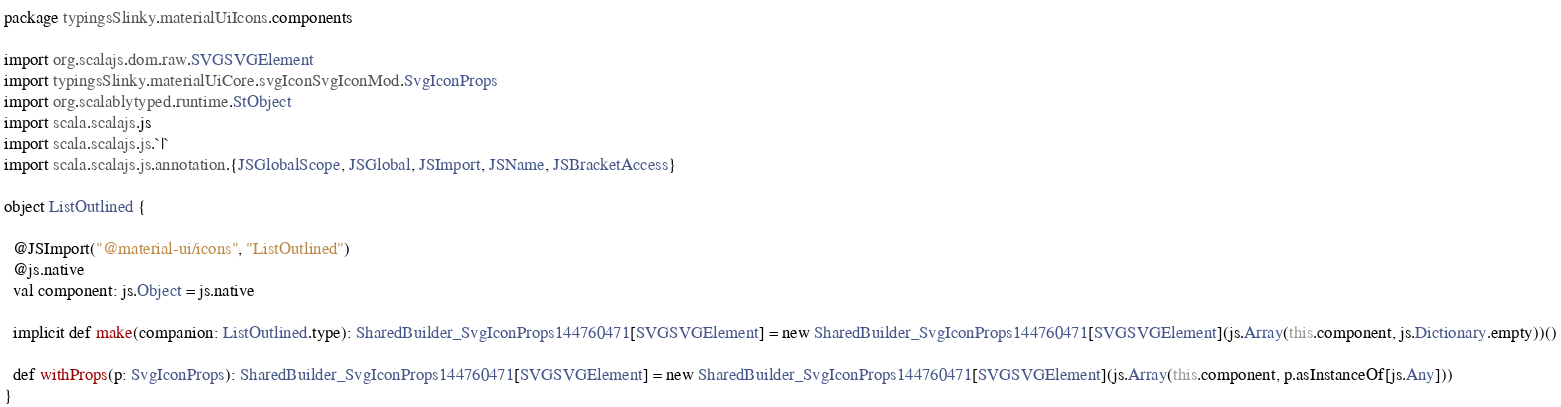Convert code to text. <code><loc_0><loc_0><loc_500><loc_500><_Scala_>package typingsSlinky.materialUiIcons.components

import org.scalajs.dom.raw.SVGSVGElement
import typingsSlinky.materialUiCore.svgIconSvgIconMod.SvgIconProps
import org.scalablytyped.runtime.StObject
import scala.scalajs.js
import scala.scalajs.js.`|`
import scala.scalajs.js.annotation.{JSGlobalScope, JSGlobal, JSImport, JSName, JSBracketAccess}

object ListOutlined {
  
  @JSImport("@material-ui/icons", "ListOutlined")
  @js.native
  val component: js.Object = js.native
  
  implicit def make(companion: ListOutlined.type): SharedBuilder_SvgIconProps144760471[SVGSVGElement] = new SharedBuilder_SvgIconProps144760471[SVGSVGElement](js.Array(this.component, js.Dictionary.empty))()
  
  def withProps(p: SvgIconProps): SharedBuilder_SvgIconProps144760471[SVGSVGElement] = new SharedBuilder_SvgIconProps144760471[SVGSVGElement](js.Array(this.component, p.asInstanceOf[js.Any]))
}
</code> 